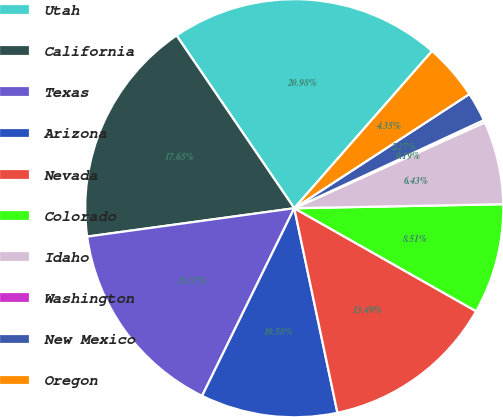<chart> <loc_0><loc_0><loc_500><loc_500><pie_chart><fcel>Utah<fcel>California<fcel>Texas<fcel>Arizona<fcel>Nevada<fcel>Colorado<fcel>Idaho<fcel>Washington<fcel>New Mexico<fcel>Oregon<nl><fcel>20.98%<fcel>17.65%<fcel>15.57%<fcel>10.58%<fcel>13.49%<fcel>8.51%<fcel>6.43%<fcel>0.19%<fcel>2.27%<fcel>4.35%<nl></chart> 